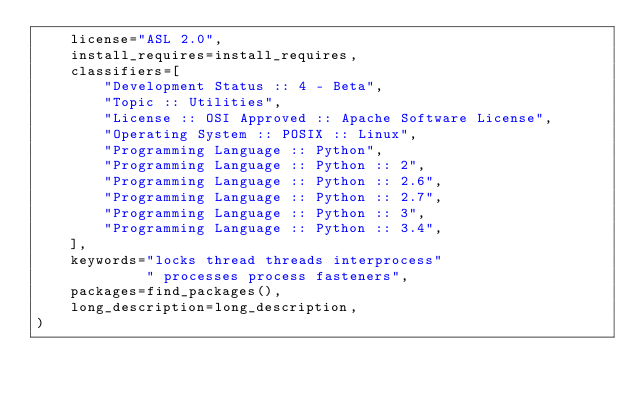<code> <loc_0><loc_0><loc_500><loc_500><_Python_>    license="ASL 2.0",
    install_requires=install_requires,
    classifiers=[
        "Development Status :: 4 - Beta",
        "Topic :: Utilities",
        "License :: OSI Approved :: Apache Software License",
        "Operating System :: POSIX :: Linux",
        "Programming Language :: Python",
        "Programming Language :: Python :: 2",
        "Programming Language :: Python :: 2.6",
        "Programming Language :: Python :: 2.7",
        "Programming Language :: Python :: 3",
        "Programming Language :: Python :: 3.4",
    ],
    keywords="locks thread threads interprocess"
             " processes process fasteners",
    packages=find_packages(),
    long_description=long_description,
)
</code> 